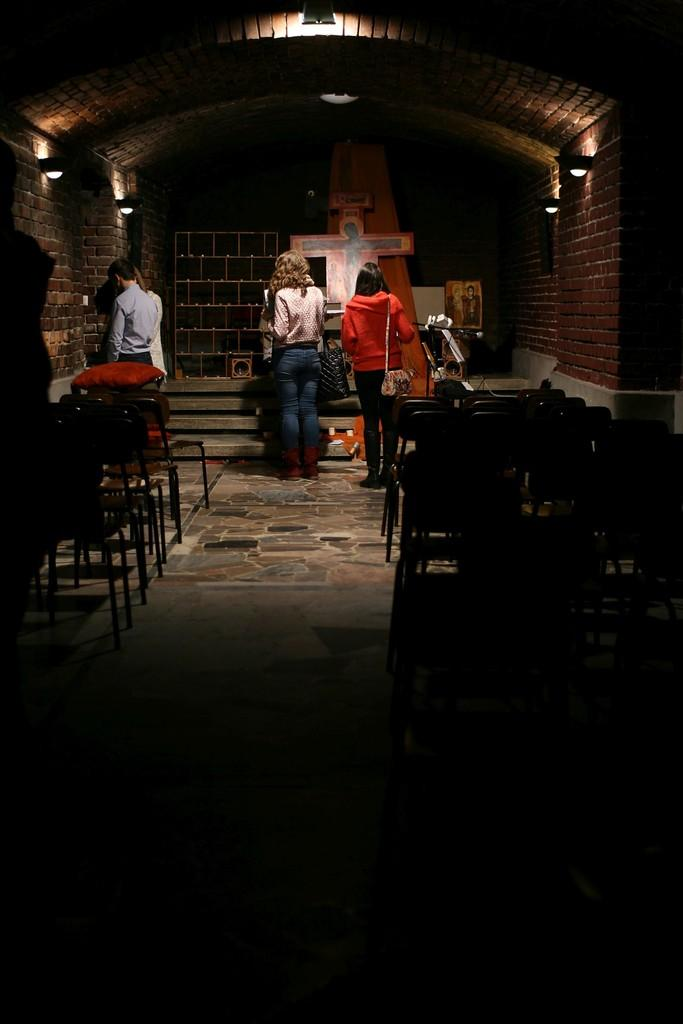What type of furniture is on the floor in the image? There are chairs on the floor in the image. What can be seen in the background of the image? There are people standing in the background, as well as lights on the wall and roof top, and other objects and frames. What type of invention is being demonstrated in the image? There is no invention being demonstrated in the image; it primarily features chairs on the floor and people in the background. 